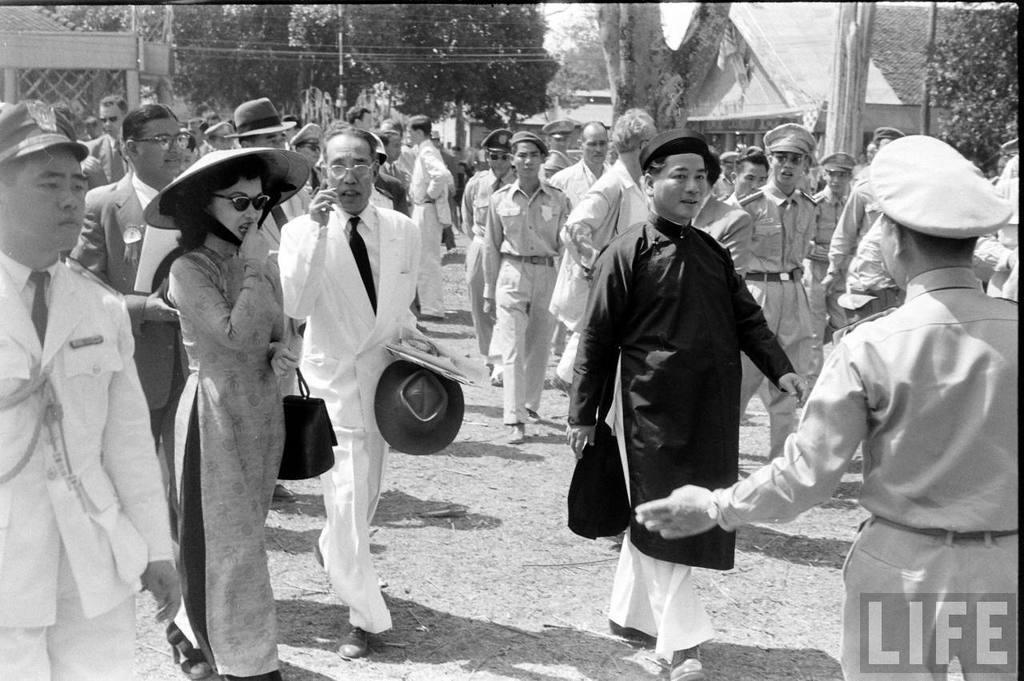Please provide a concise description of this image. In this picture there are group of people walking. At the back there are buildings and trees and there are poles. At the bottom there is ground. At the bottom right there is text. 